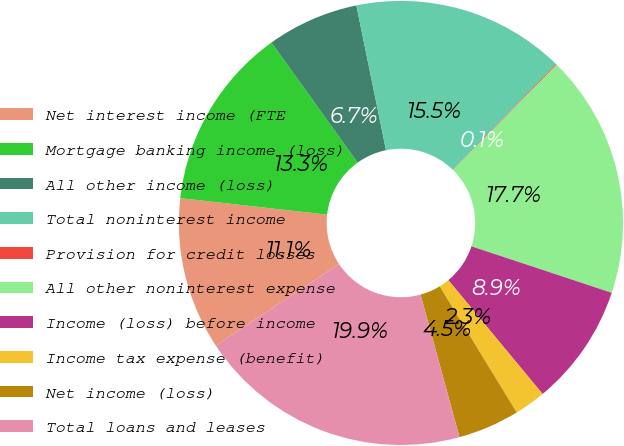<chart> <loc_0><loc_0><loc_500><loc_500><pie_chart><fcel>Net interest income (FTE<fcel>Mortgage banking income (loss)<fcel>All other income (loss)<fcel>Total noninterest income<fcel>Provision for credit losses<fcel>All other noninterest expense<fcel>Income (loss) before income<fcel>Income tax expense (benefit)<fcel>Net income (loss)<fcel>Total loans and leases<nl><fcel>11.1%<fcel>13.31%<fcel>6.69%<fcel>15.52%<fcel>0.07%<fcel>17.72%<fcel>8.9%<fcel>2.28%<fcel>4.48%<fcel>19.93%<nl></chart> 